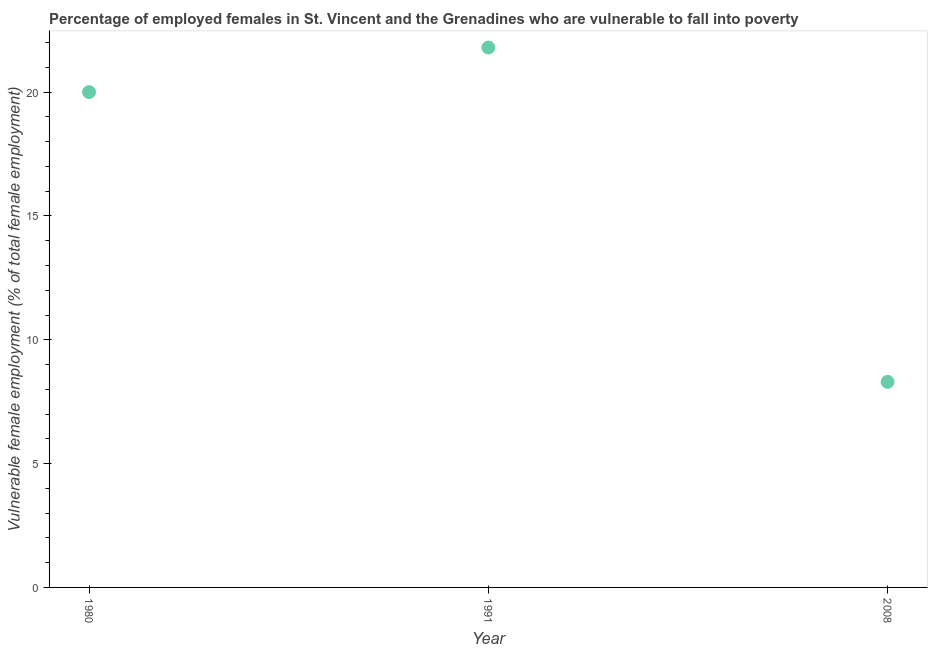What is the percentage of employed females who are vulnerable to fall into poverty in 1991?
Provide a short and direct response. 21.8. Across all years, what is the maximum percentage of employed females who are vulnerable to fall into poverty?
Keep it short and to the point. 21.8. Across all years, what is the minimum percentage of employed females who are vulnerable to fall into poverty?
Make the answer very short. 8.3. In which year was the percentage of employed females who are vulnerable to fall into poverty maximum?
Your response must be concise. 1991. In which year was the percentage of employed females who are vulnerable to fall into poverty minimum?
Keep it short and to the point. 2008. What is the sum of the percentage of employed females who are vulnerable to fall into poverty?
Provide a short and direct response. 50.1. What is the difference between the percentage of employed females who are vulnerable to fall into poverty in 1980 and 2008?
Offer a very short reply. 11.7. What is the average percentage of employed females who are vulnerable to fall into poverty per year?
Provide a short and direct response. 16.7. Do a majority of the years between 1991 and 2008 (inclusive) have percentage of employed females who are vulnerable to fall into poverty greater than 16 %?
Keep it short and to the point. No. What is the ratio of the percentage of employed females who are vulnerable to fall into poverty in 1980 to that in 1991?
Your response must be concise. 0.92. Is the percentage of employed females who are vulnerable to fall into poverty in 1980 less than that in 2008?
Your answer should be very brief. No. Is the difference between the percentage of employed females who are vulnerable to fall into poverty in 1980 and 1991 greater than the difference between any two years?
Offer a very short reply. No. What is the difference between the highest and the second highest percentage of employed females who are vulnerable to fall into poverty?
Keep it short and to the point. 1.8. Is the sum of the percentage of employed females who are vulnerable to fall into poverty in 1991 and 2008 greater than the maximum percentage of employed females who are vulnerable to fall into poverty across all years?
Provide a succinct answer. Yes. What is the difference between the highest and the lowest percentage of employed females who are vulnerable to fall into poverty?
Your answer should be compact. 13.5. How many dotlines are there?
Offer a terse response. 1. How many years are there in the graph?
Keep it short and to the point. 3. Are the values on the major ticks of Y-axis written in scientific E-notation?
Make the answer very short. No. Does the graph contain any zero values?
Provide a short and direct response. No. What is the title of the graph?
Offer a terse response. Percentage of employed females in St. Vincent and the Grenadines who are vulnerable to fall into poverty. What is the label or title of the X-axis?
Ensure brevity in your answer.  Year. What is the label or title of the Y-axis?
Your response must be concise. Vulnerable female employment (% of total female employment). What is the Vulnerable female employment (% of total female employment) in 1980?
Offer a terse response. 20. What is the Vulnerable female employment (% of total female employment) in 1991?
Provide a succinct answer. 21.8. What is the Vulnerable female employment (% of total female employment) in 2008?
Provide a succinct answer. 8.3. What is the difference between the Vulnerable female employment (% of total female employment) in 1980 and 2008?
Provide a succinct answer. 11.7. What is the difference between the Vulnerable female employment (% of total female employment) in 1991 and 2008?
Your answer should be very brief. 13.5. What is the ratio of the Vulnerable female employment (% of total female employment) in 1980 to that in 1991?
Ensure brevity in your answer.  0.92. What is the ratio of the Vulnerable female employment (% of total female employment) in 1980 to that in 2008?
Give a very brief answer. 2.41. What is the ratio of the Vulnerable female employment (% of total female employment) in 1991 to that in 2008?
Your answer should be very brief. 2.63. 